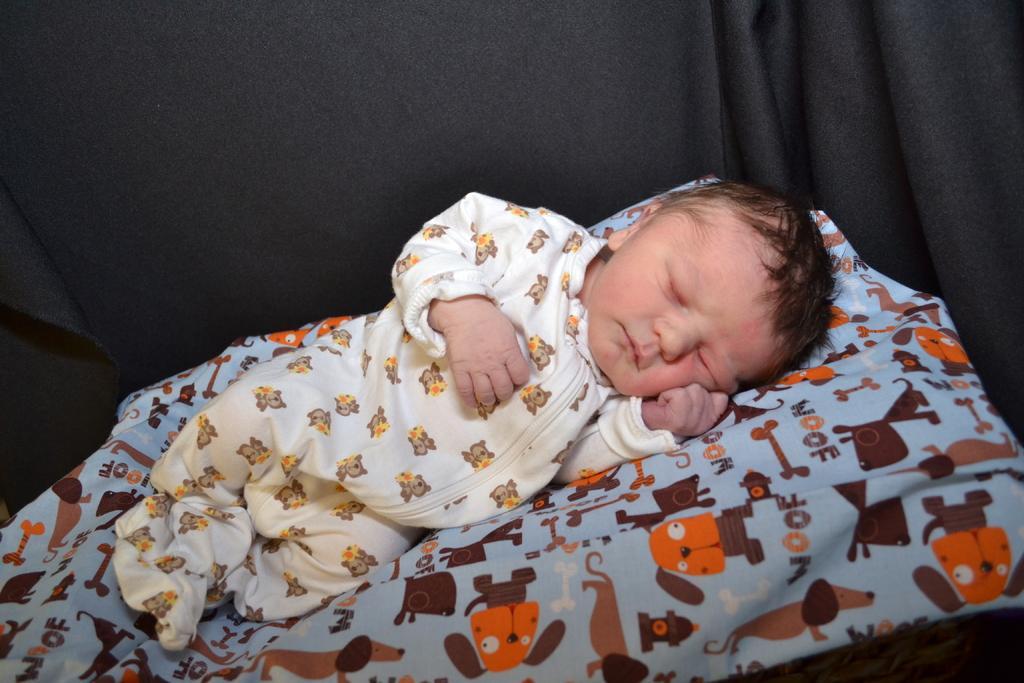Describe this image in one or two sentences. In the picture we can see a baby sleeping on the bed and behind the baby we can see a black color curtain. 